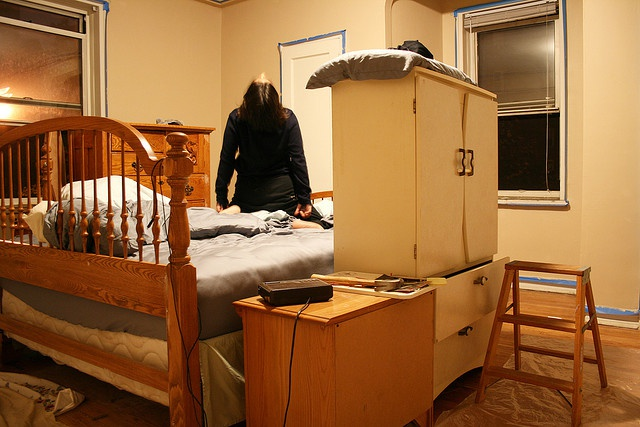Describe the objects in this image and their specific colors. I can see bed in black, maroon, brown, and beige tones and people in black, tan, and maroon tones in this image. 